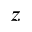<formula> <loc_0><loc_0><loc_500><loc_500>z</formula> 